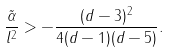<formula> <loc_0><loc_0><loc_500><loc_500>\frac { \tilde { \alpha } } { l ^ { 2 } } > - \frac { ( d - 3 ) ^ { 2 } } { 4 ( d - 1 ) ( d - 5 ) } .</formula> 